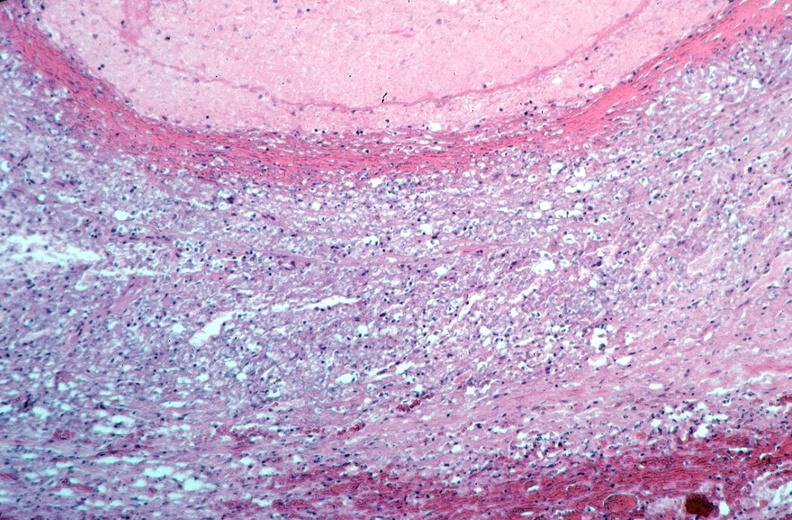s coronary artery present?
Answer the question using a single word or phrase. No 